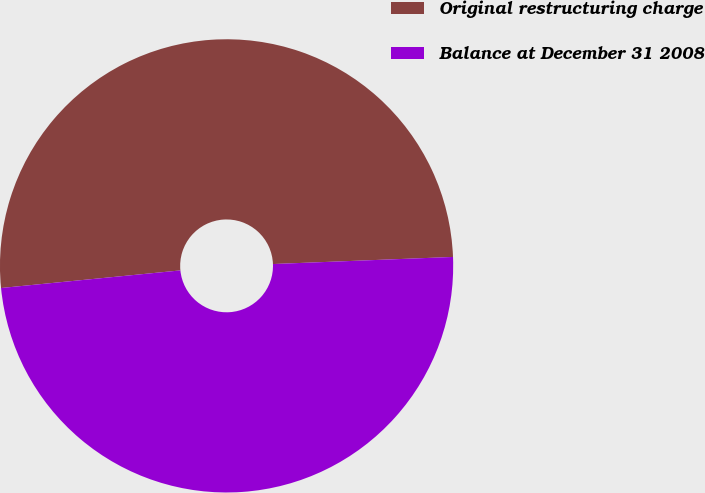Convert chart to OTSL. <chart><loc_0><loc_0><loc_500><loc_500><pie_chart><fcel>Original restructuring charge<fcel>Balance at December 31 2008<nl><fcel>50.93%<fcel>49.07%<nl></chart> 